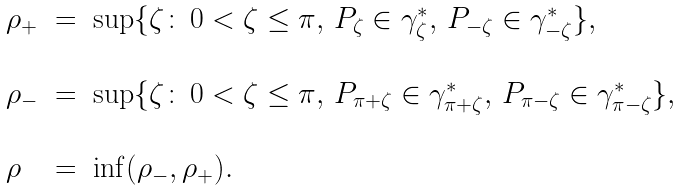Convert formula to latex. <formula><loc_0><loc_0><loc_500><loc_500>\begin{array} { l l l } \rho _ { + } & = & \sup \{ \zeta \colon \, 0 < \zeta \leq \pi , \, P _ { \zeta } \in \gamma ^ { * } _ { \zeta } , \, P _ { - \zeta } \in \gamma ^ { * } _ { - \zeta } \} , \\ \\ \rho _ { - } & = & \sup \{ \zeta \colon \, 0 < \zeta \leq \pi , \, P _ { \pi + \zeta } \in \gamma ^ { * } _ { \pi + \zeta } , \, P _ { \pi - \zeta } \in \gamma ^ { * } _ { \pi - \zeta } \} , \\ \\ \rho & = & \inf ( \rho _ { - } , \rho _ { + } ) . \end{array}</formula> 